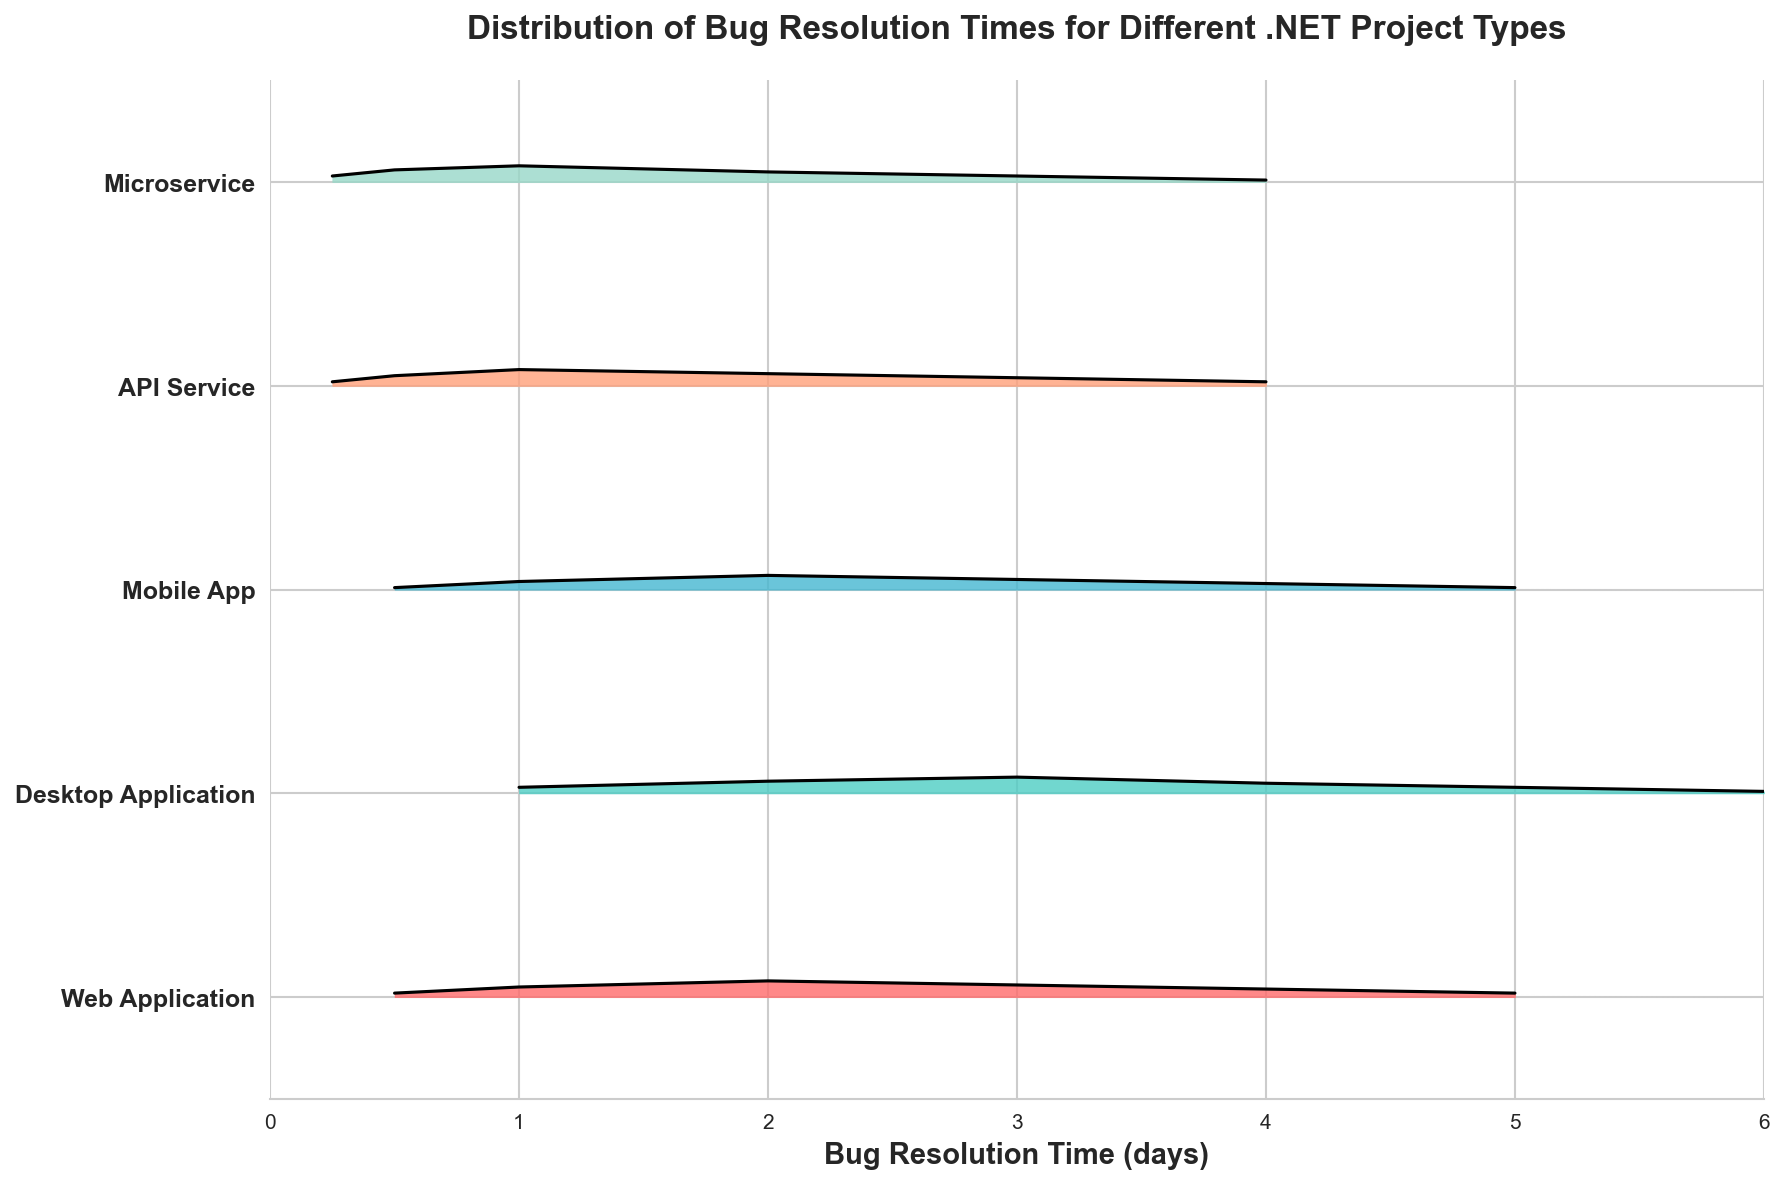What's the title of the plot? The title of the plot is positioned at the top center part of the figure, above the axes and visual elements. You can find it written clearly in bold text.
Answer: Distribution of Bug Resolution Times for Different .NET Project Types What's on the x-axis and y-axis of the plot? The x-axis, located horizontally at the bottom of the plot, is labeled with "Bug Resolution Time (days)." The y-axis, oriented vertically on the left side of the plot, lists the different project types.
Answer: Bug Resolution Time (days) and Project Types Which project type has the widest distribution of bug resolution times? By looking at the width of the filled areas for each project type, the "Desktop Application" and "Microservice" project types have the widest distributions as their curves span a larger range along the x-axis.
Answer: Desktop Application and Microservice Which project type appears to have the shortest maximum bug resolution time? To find the shortest maximum bug resolution time, look for the project type whose distribution ends earliest along the x-axis. "Mobile App" seems to have the shortest maximum bug resolution time.
Answer: Mobile App For which project types do the highest peaks occur at the same resolution time? By observing the peaks of the distributions, both "Web Application" and "Microservice" reach their highest peak around 1 day on the x-axis.
Answer: Web Application and Microservice What is the bug resolution time with the highest density for API Service? The highest peak for API Service in the ridgeline plot occurs at about 1 day. The line reaches its maximum height at this point.
Answer: 1 day Which project type shows a clear peak around 2 days in bug resolution times? The ridgelines with a noticeable peak around 2 days can be observed by looking at which distribution curves rise significantly at the 2-day mark on the x-axis. "Desktop Application" shows a clear peak around 2 days.
Answer: Desktop Application Compare the densities at 3 days for Mobile App and Web Application. Which is higher? To compare these densities, locate the 3-day mark on the x-axis for both Mobile App and Web Application and see the height of the distribution curves. Web Application has a higher density at 3 days compared to Mobile App.
Answer: Web Application At which bug resolution time does Desktop Application start to show non-zero density? The initial non-zero density for Desktop Application can be recognized by observing the starting point of its curve along the x-axis, which seems to occur at 1 day.
Answer: 1 day Which project type shows the least variation in bug resolution times? Least variation can be identified by the narrowness of the distribution in the ridgeline plot. "Mobile App" displays the least variation as its distributions are narrowly concentrated.
Answer: Mobile App 